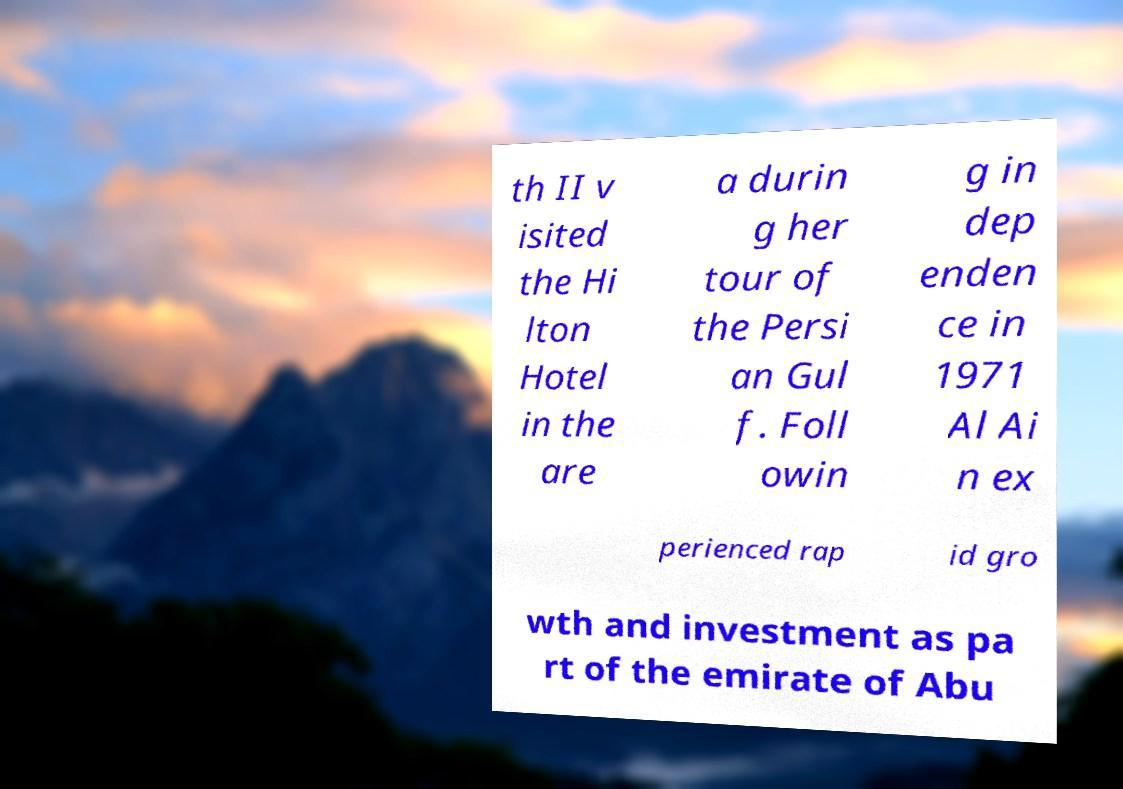Can you accurately transcribe the text from the provided image for me? th II v isited the Hi lton Hotel in the are a durin g her tour of the Persi an Gul f. Foll owin g in dep enden ce in 1971 Al Ai n ex perienced rap id gro wth and investment as pa rt of the emirate of Abu 